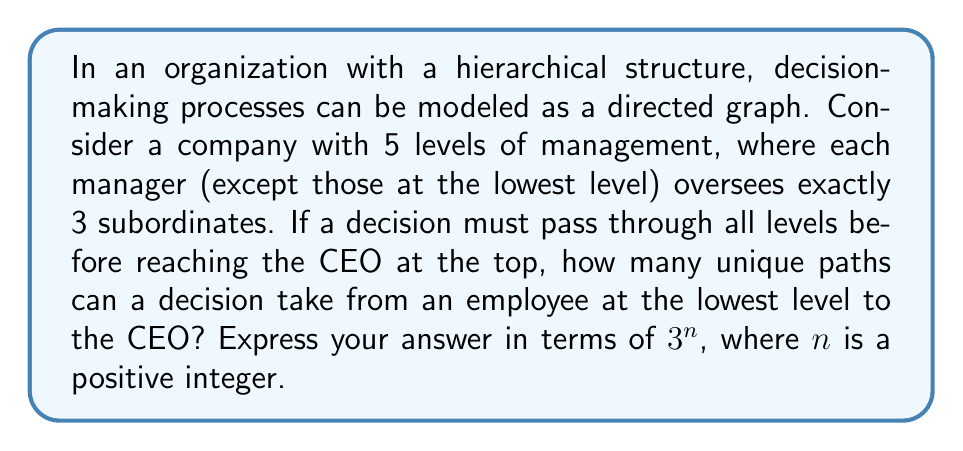What is the answer to this math problem? To solve this problem, we need to consider the topology of the organizational hierarchy and apply concepts from graph theory. Let's approach this step-by-step:

1) First, let's visualize the structure:
   - Level 5 (bottom): Employees
   - Level 4: First-line managers
   - Level 3: Middle managers
   - Level 2: Senior managers
   - Level 1 (top): CEO

2) Each employee's decision must pass through exactly 4 managers (one at each level) before reaching the CEO.

3) At each level (except the top), an employee or manager has exactly one superior to report to.

4) The number of paths from any given employee to the CEO is determined by the number of choices at each level above them.

5) Starting from the bottom:
   - An employee has 1 choice for their immediate manager
   - That manager has 1 choice for their superior
   - The middle manager has 1 choice for their superior
   - The senior manager has 1 choice (the CEO)

6) However, we need to consider all employees at the lowest level. The number of employees at the lowest level can be calculated as follows:
   $$3 * 3 * 3 * 3 = 3^4 = 81$$

7) Each of these 81 employees has exactly one unique path to the CEO.

8) Therefore, the total number of unique paths is equal to the number of employees at the lowest level, which is $3^4$.

9) We can express this as $3^n$ where $n = 4$.
Answer: $3^4$ unique paths, or 81 paths. 